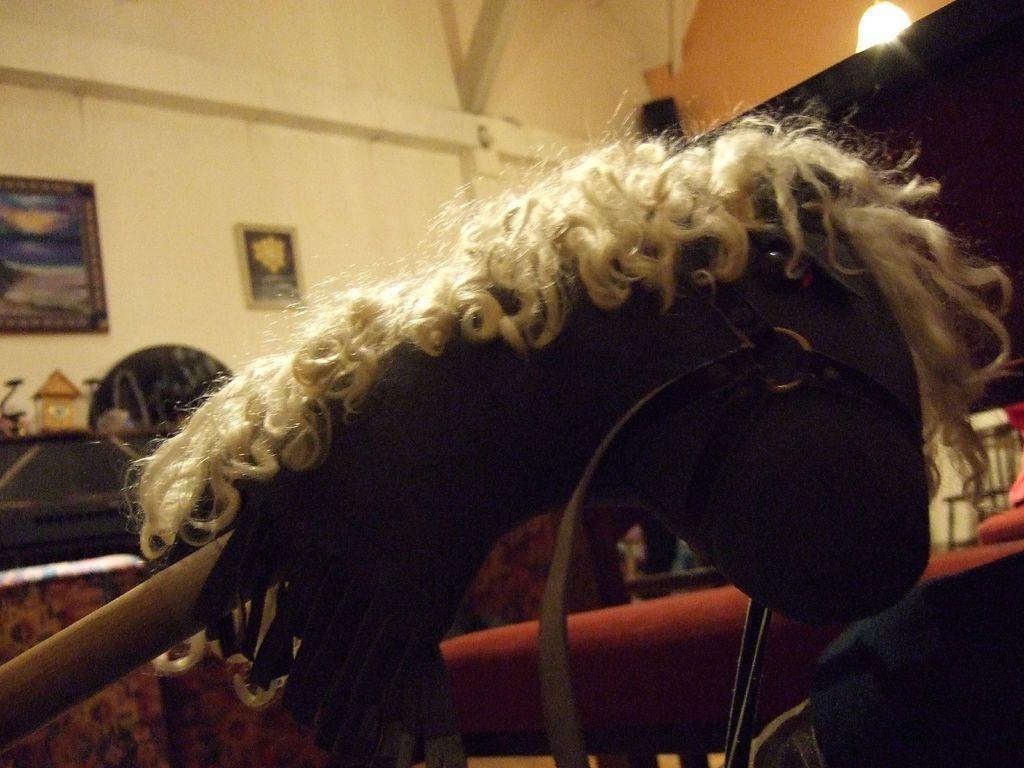How would you summarize this image in a sentence or two? In this image we can see a doll hanged to the stick, wall hangings attached to the wall and electric light hanging from the top. 